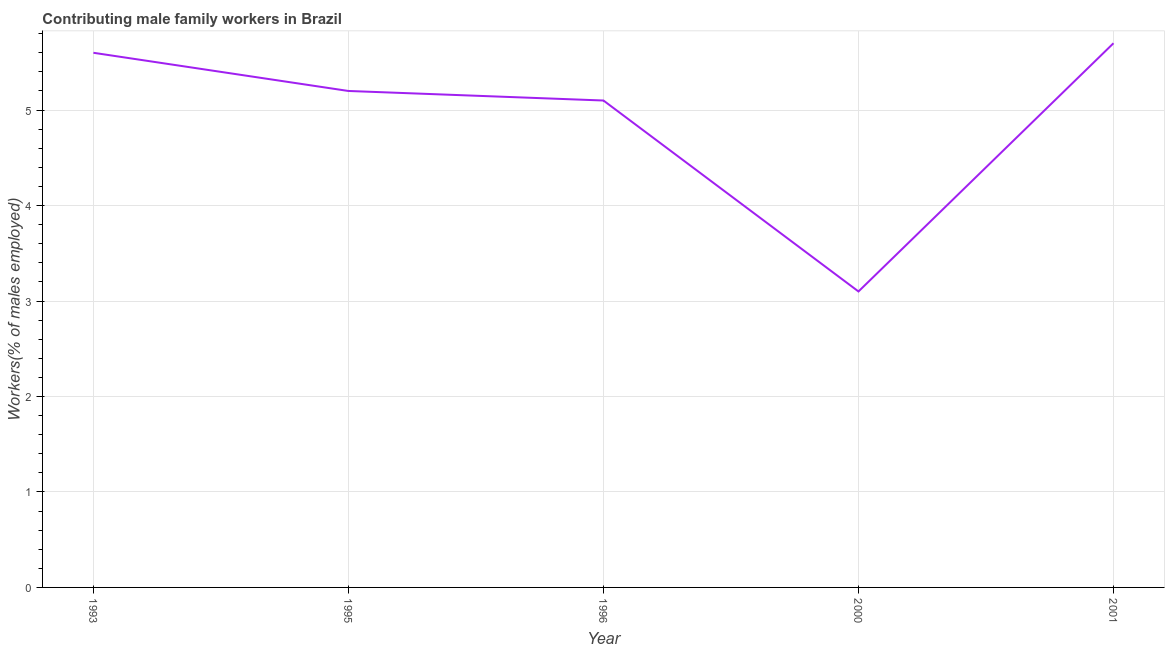What is the contributing male family workers in 1993?
Your answer should be very brief. 5.6. Across all years, what is the maximum contributing male family workers?
Keep it short and to the point. 5.7. Across all years, what is the minimum contributing male family workers?
Your answer should be very brief. 3.1. In which year was the contributing male family workers maximum?
Ensure brevity in your answer.  2001. What is the sum of the contributing male family workers?
Keep it short and to the point. 24.7. What is the difference between the contributing male family workers in 1995 and 1996?
Offer a very short reply. 0.1. What is the average contributing male family workers per year?
Your response must be concise. 4.94. What is the median contributing male family workers?
Make the answer very short. 5.2. Do a majority of the years between 2001 and 1996 (inclusive) have contributing male family workers greater than 5.6 %?
Provide a succinct answer. No. What is the ratio of the contributing male family workers in 1993 to that in 1996?
Give a very brief answer. 1.1. Is the contributing male family workers in 1993 less than that in 1995?
Offer a terse response. No. Is the difference between the contributing male family workers in 2000 and 2001 greater than the difference between any two years?
Offer a terse response. Yes. What is the difference between the highest and the second highest contributing male family workers?
Your answer should be compact. 0.1. What is the difference between the highest and the lowest contributing male family workers?
Ensure brevity in your answer.  2.6. In how many years, is the contributing male family workers greater than the average contributing male family workers taken over all years?
Give a very brief answer. 4. What is the difference between two consecutive major ticks on the Y-axis?
Your answer should be compact. 1. Are the values on the major ticks of Y-axis written in scientific E-notation?
Your answer should be compact. No. Does the graph contain any zero values?
Offer a terse response. No. What is the title of the graph?
Make the answer very short. Contributing male family workers in Brazil. What is the label or title of the X-axis?
Your response must be concise. Year. What is the label or title of the Y-axis?
Keep it short and to the point. Workers(% of males employed). What is the Workers(% of males employed) in 1993?
Provide a short and direct response. 5.6. What is the Workers(% of males employed) of 1995?
Offer a very short reply. 5.2. What is the Workers(% of males employed) in 1996?
Offer a terse response. 5.1. What is the Workers(% of males employed) of 2000?
Offer a terse response. 3.1. What is the Workers(% of males employed) in 2001?
Give a very brief answer. 5.7. What is the difference between the Workers(% of males employed) in 1993 and 1995?
Give a very brief answer. 0.4. What is the difference between the Workers(% of males employed) in 1993 and 1996?
Provide a succinct answer. 0.5. What is the difference between the Workers(% of males employed) in 1993 and 2001?
Offer a very short reply. -0.1. What is the difference between the Workers(% of males employed) in 1995 and 2000?
Offer a very short reply. 2.1. What is the difference between the Workers(% of males employed) in 1995 and 2001?
Give a very brief answer. -0.5. What is the difference between the Workers(% of males employed) in 1996 and 2000?
Ensure brevity in your answer.  2. What is the difference between the Workers(% of males employed) in 1996 and 2001?
Provide a short and direct response. -0.6. What is the ratio of the Workers(% of males employed) in 1993 to that in 1995?
Ensure brevity in your answer.  1.08. What is the ratio of the Workers(% of males employed) in 1993 to that in 1996?
Make the answer very short. 1.1. What is the ratio of the Workers(% of males employed) in 1993 to that in 2000?
Keep it short and to the point. 1.81. What is the ratio of the Workers(% of males employed) in 1993 to that in 2001?
Offer a terse response. 0.98. What is the ratio of the Workers(% of males employed) in 1995 to that in 2000?
Make the answer very short. 1.68. What is the ratio of the Workers(% of males employed) in 1995 to that in 2001?
Your response must be concise. 0.91. What is the ratio of the Workers(% of males employed) in 1996 to that in 2000?
Offer a very short reply. 1.65. What is the ratio of the Workers(% of males employed) in 1996 to that in 2001?
Provide a succinct answer. 0.9. What is the ratio of the Workers(% of males employed) in 2000 to that in 2001?
Provide a short and direct response. 0.54. 